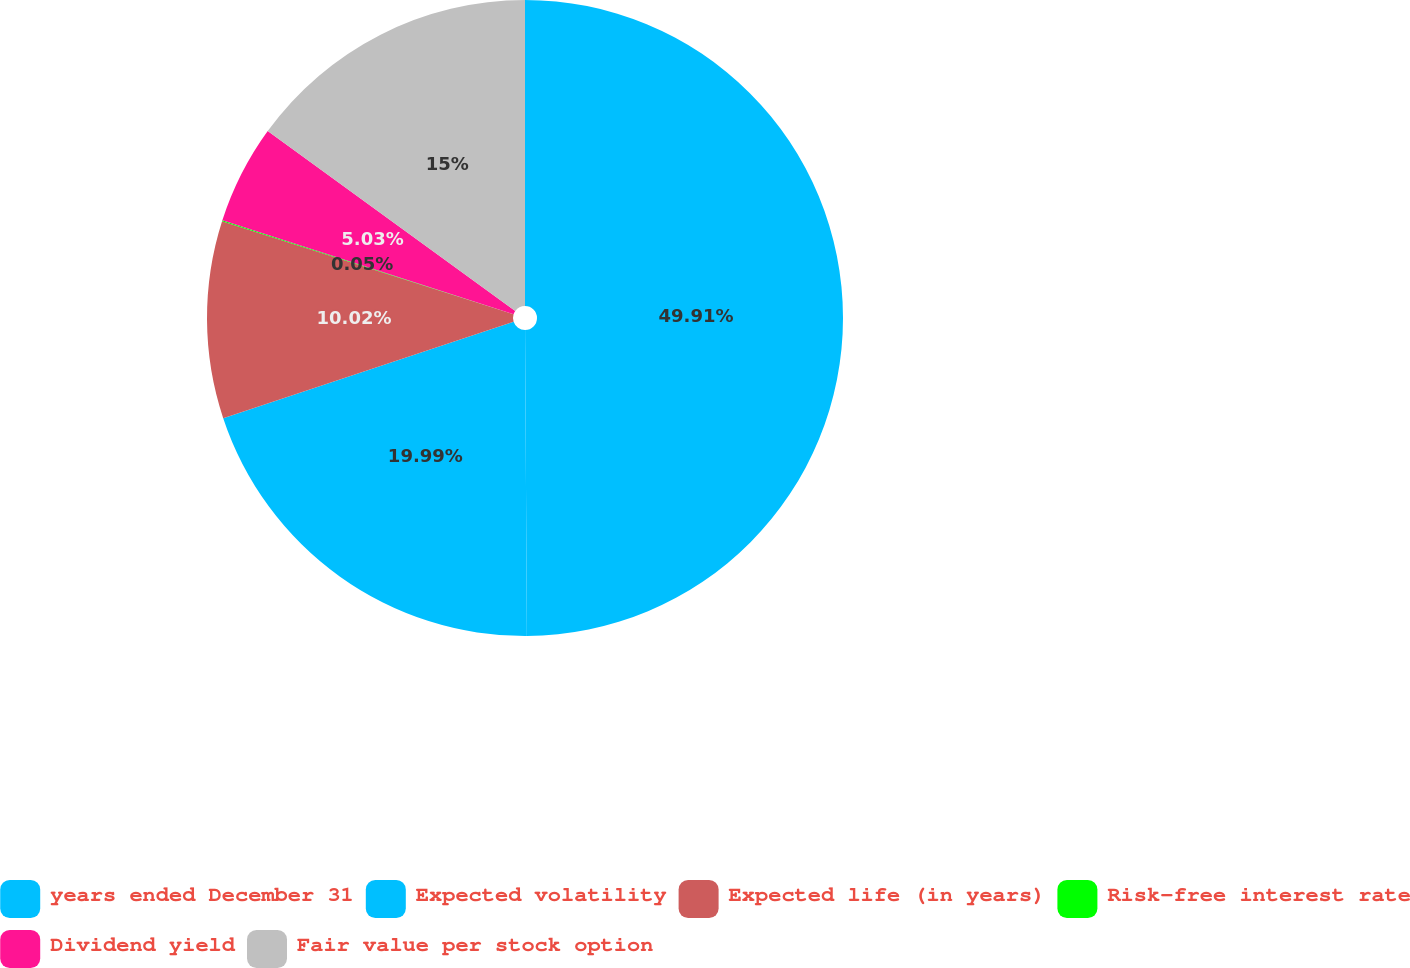<chart> <loc_0><loc_0><loc_500><loc_500><pie_chart><fcel>years ended December 31<fcel>Expected volatility<fcel>Expected life (in years)<fcel>Risk-free interest rate<fcel>Dividend yield<fcel>Fair value per stock option<nl><fcel>49.9%<fcel>19.99%<fcel>10.02%<fcel>0.05%<fcel>5.03%<fcel>15.0%<nl></chart> 